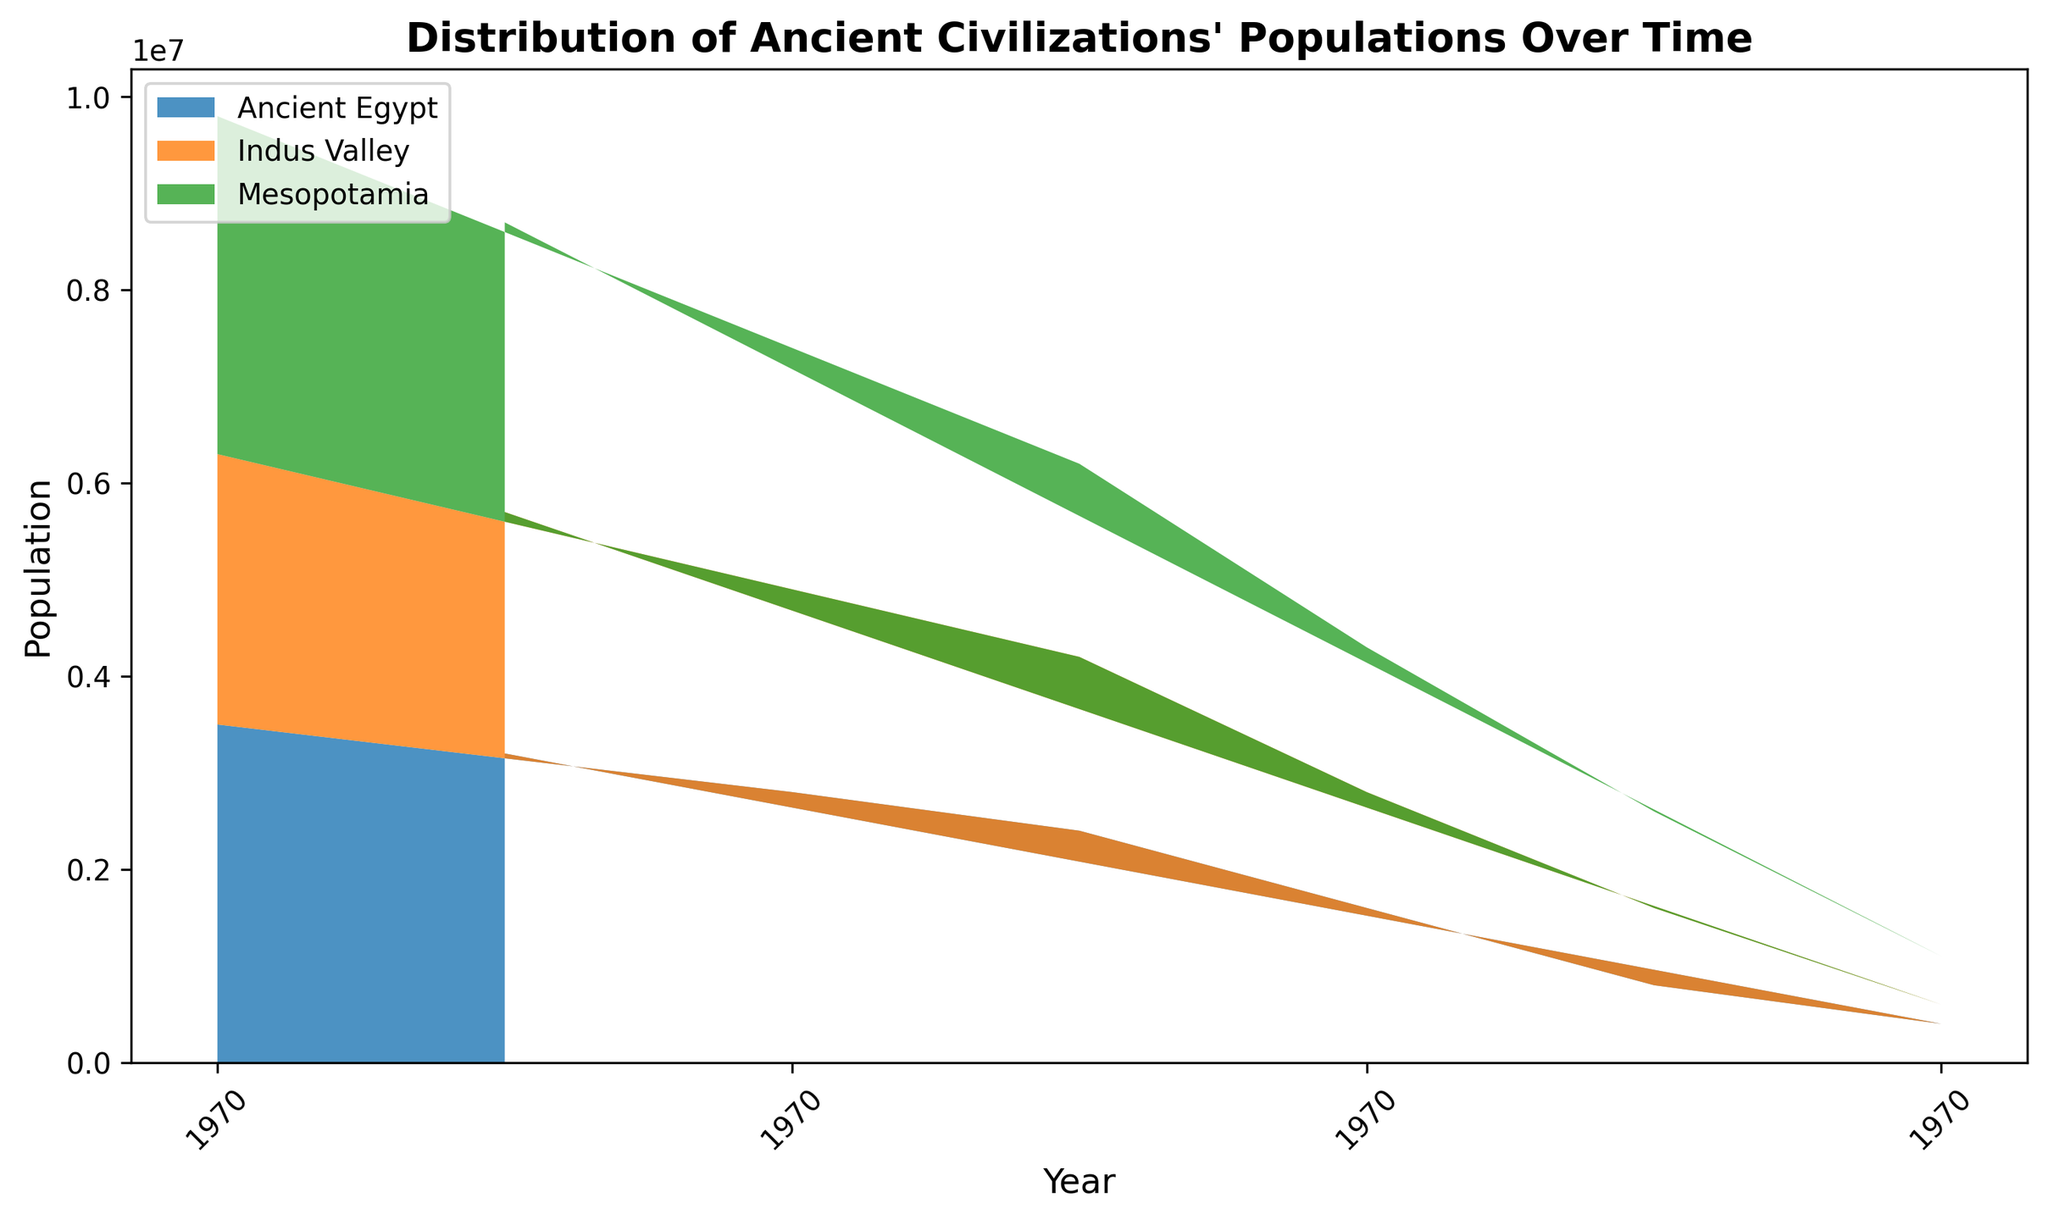Which region had the highest population in 0 CE? Referring to the area chart, the highest population in 0 CE would be indicated by the region with the tallest area band at that year. Mesopotamia and Ancient Egypt both had the highest population, represented by the tallest areas at the 0 CE mark.
Answer: Mesopotamia and Ancient Egypt How did the population of the Indus Valley change from 2000 BCE to 500 CE? To determine the change in population, observe the height of the area representing the Indus Valley in 2000 BCE and compare it to the height in 500 CE. The population decreased from 1,200,000 in 2000 BCE to 2,000,000 in 500 CE.
Answer: Decreased Which region’s population grew the most from 3000 BCE to 500 BCE? Compare the height difference in the area bands for each region between the years 3000 BCE and 500 BCE. Ancient Egypt's population shows the greatest increase in area height, growing by 2,800,000.
Answer: Ancient Egypt Did any region experience a population decline from 0 CE to 500 CE? Look for any decrease in the height of the area representing each region from 0 CE to 500 CE. Both Mesopotamia and the Indus Valley show a decline in population. Mesopotamia's population dropped by 700,000 and the Indus Valley's population dropped by 800,000.
Answer: Yes Which region had the lowest population in 1500 BCE? Identify the shortest area band at the 1500 BCE mark on the chart. The Indus Valley had the smallest area height in 1500 BCE, indicating the lowest population, 1,800,000.
Answer: Indus Valley What was the combined population of Mesopotamia and Ancient Egypt in 1000 BCE? Sum the populations of Mesopotamia and Ancient Egypt at 1000 BCE. Mesopotamia had 2,500,000 and Ancient Egypt had 2,800,000. Combined, they make 5,300,000.
Answer: 5,300,000 How does the population trend of Ancient Egypt from 3000 BCE to 500 CE compare to Mesopotamia? Both regions show an increasing trend from 3000 BCE to 0 CE with Ancient Egypt peaking and then both populations decline by 500 CE. However, Ancient Egypt consistently shows higher peak populations over time compared to Mesopotamia.
Answer: Both increased then declined; Ancient Egypt consistently higher Between which two consecutive time periods did Mesopotamia see the highest population increase? By examining the area chart, the greatest change in area height for Mesopotamia is between 3000 BCE to 2000 BCE where the population increased by 1,000,000.
Answer: 2500 BCE to 2000 BCE Which region showed the least variation in population size throughout the timeline? Observe the relative stability of the height of the area bands for each region. The Indus Valley shows the least variation in height, indicating a more stable population.
Answer: Indus Valley In what year did Ancient Egypt's population first surpass the population of the Indus Valley? Compare the height of Ancient Egypt's area to the Indus Valley's area across the timeline to find the first intersection point. Ancient Egypt's population surpassed the Indus Valley around 2000 BCE.
Answer: 2000 BCE 